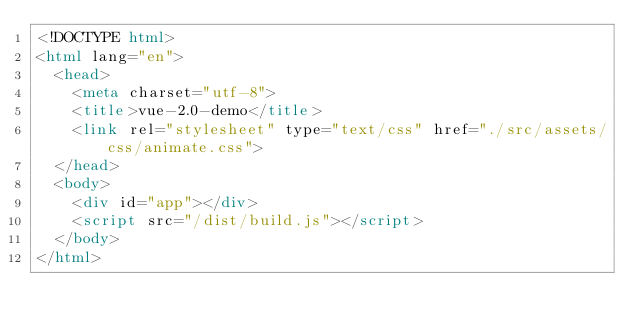<code> <loc_0><loc_0><loc_500><loc_500><_HTML_><!DOCTYPE html>
<html lang="en">
  <head>
    <meta charset="utf-8">
    <title>vue-2.0-demo</title>
    <link rel="stylesheet" type="text/css" href="./src/assets/css/animate.css">
  </head>
  <body>
    <div id="app"></div>
    <script src="/dist/build.js"></script>
  </body>
</html>
</code> 